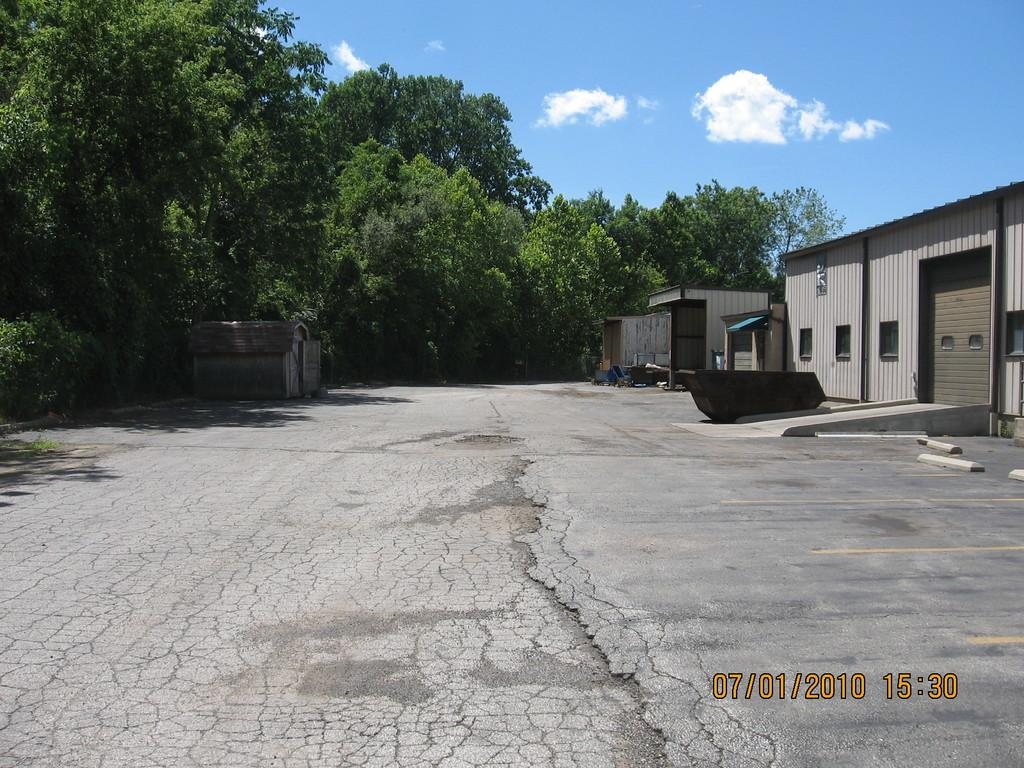What type of natural elements can be seen in the image? There are trees in the image. What type of man-made structures are present in the image? There are garages in the image. What is located on the ground in the image? There is an object on the ground in the image. What type of transportation infrastructure is visible in the image? There is a road in the image. What part of the natural environment is visible in the image? The sky is visible in the image. What type of weather can be inferred from the image? The presence of clouds in the sky suggests that it might be a partly cloudy day. What arithmetic problem is being solved on the sidewalk in the image? There is no arithmetic problem or sidewalk present in the image. What type of needle is being used to sew the clouds in the image? There is no needle or sewing activity present in the image; the clouds are a natural weather phenomenon. 